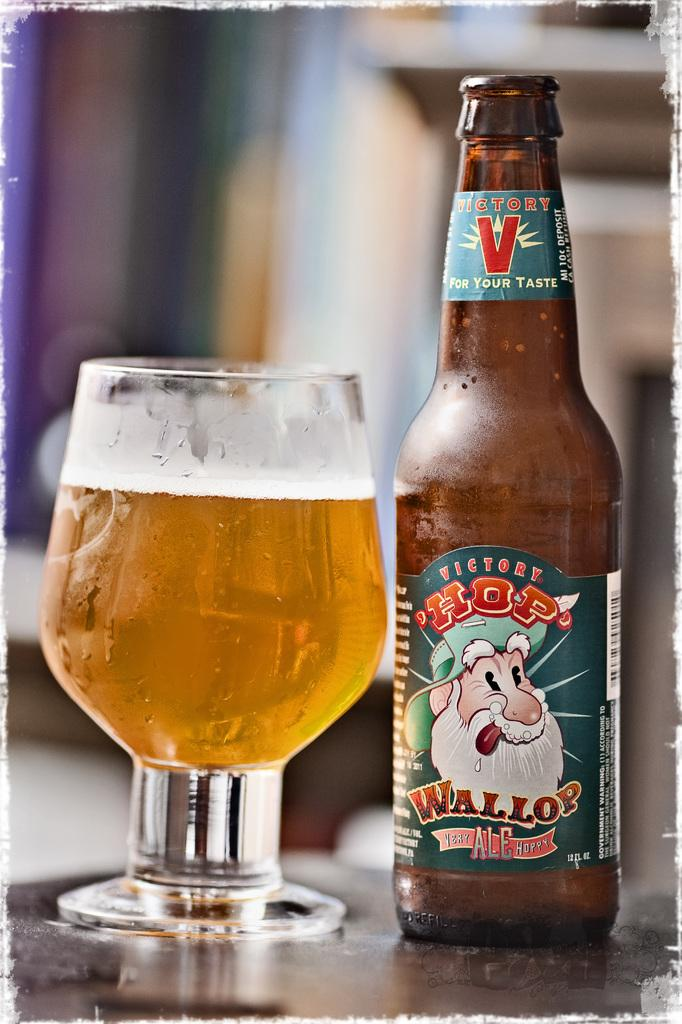<image>
Write a terse but informative summary of the picture. A bottle of Victory Hop Wallop Ale with the beer poured into a glass chalice. 